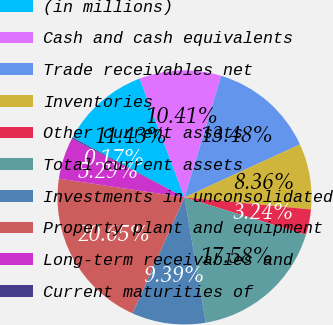<chart> <loc_0><loc_0><loc_500><loc_500><pie_chart><fcel>(in millions)<fcel>Cash and cash equivalents<fcel>Trade receivables net<fcel>Inventories<fcel>Other current assets<fcel>Total current assets<fcel>Investments in unconsolidated<fcel>Property plant and equipment<fcel>Long-term receivables and<fcel>Current maturities of<nl><fcel>11.43%<fcel>10.41%<fcel>13.48%<fcel>8.36%<fcel>3.24%<fcel>17.58%<fcel>9.39%<fcel>20.65%<fcel>5.29%<fcel>0.17%<nl></chart> 